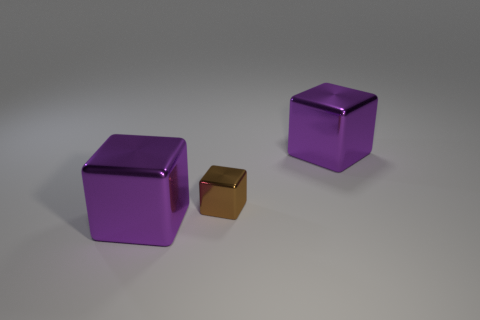Subtract all green cylinders. How many purple cubes are left? 2 Add 1 metal objects. How many objects exist? 4 Add 1 brown shiny blocks. How many brown shiny blocks exist? 2 Subtract 0 yellow cubes. How many objects are left? 3 Subtract all small brown cubes. Subtract all brown objects. How many objects are left? 1 Add 2 brown objects. How many brown objects are left? 3 